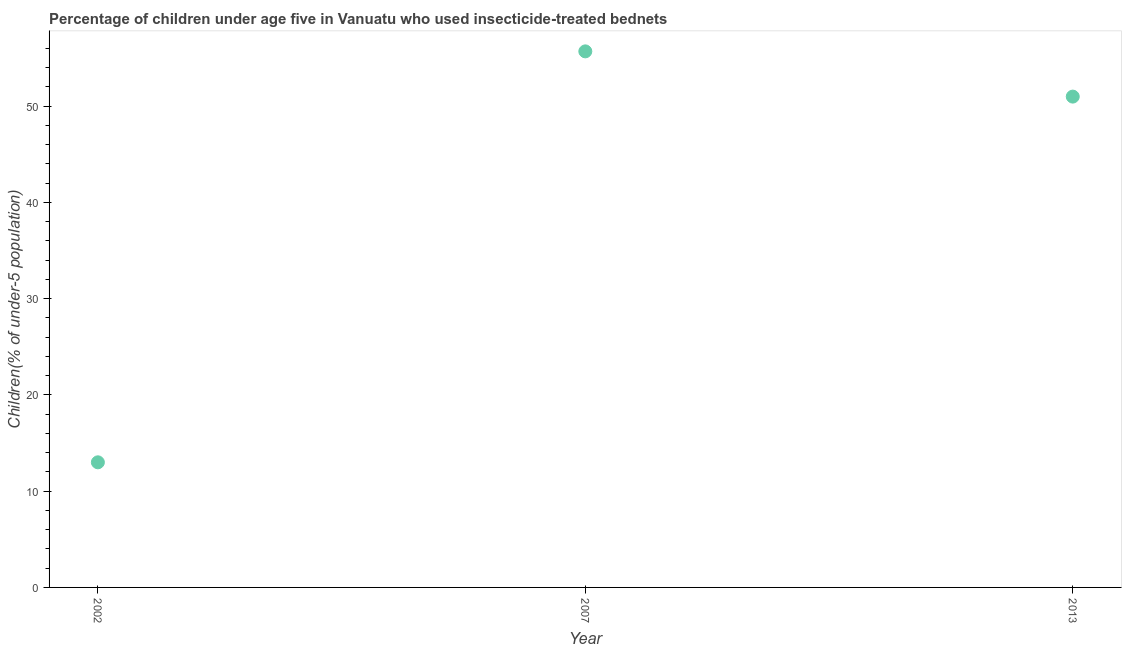What is the percentage of children who use of insecticide-treated bed nets in 2013?
Provide a short and direct response. 51. Across all years, what is the maximum percentage of children who use of insecticide-treated bed nets?
Provide a short and direct response. 55.7. What is the sum of the percentage of children who use of insecticide-treated bed nets?
Ensure brevity in your answer.  119.7. What is the difference between the percentage of children who use of insecticide-treated bed nets in 2007 and 2013?
Give a very brief answer. 4.7. What is the average percentage of children who use of insecticide-treated bed nets per year?
Give a very brief answer. 39.9. What is the ratio of the percentage of children who use of insecticide-treated bed nets in 2002 to that in 2013?
Make the answer very short. 0.25. Is the percentage of children who use of insecticide-treated bed nets in 2007 less than that in 2013?
Ensure brevity in your answer.  No. What is the difference between the highest and the second highest percentage of children who use of insecticide-treated bed nets?
Ensure brevity in your answer.  4.7. Is the sum of the percentage of children who use of insecticide-treated bed nets in 2007 and 2013 greater than the maximum percentage of children who use of insecticide-treated bed nets across all years?
Keep it short and to the point. Yes. What is the difference between the highest and the lowest percentage of children who use of insecticide-treated bed nets?
Provide a succinct answer. 42.7. Does the percentage of children who use of insecticide-treated bed nets monotonically increase over the years?
Your response must be concise. No. How many years are there in the graph?
Provide a succinct answer. 3. What is the difference between two consecutive major ticks on the Y-axis?
Offer a terse response. 10. Does the graph contain grids?
Your answer should be very brief. No. What is the title of the graph?
Provide a short and direct response. Percentage of children under age five in Vanuatu who used insecticide-treated bednets. What is the label or title of the X-axis?
Provide a succinct answer. Year. What is the label or title of the Y-axis?
Offer a very short reply. Children(% of under-5 population). What is the Children(% of under-5 population) in 2007?
Provide a succinct answer. 55.7. What is the difference between the Children(% of under-5 population) in 2002 and 2007?
Offer a terse response. -42.7. What is the difference between the Children(% of under-5 population) in 2002 and 2013?
Ensure brevity in your answer.  -38. What is the ratio of the Children(% of under-5 population) in 2002 to that in 2007?
Your answer should be compact. 0.23. What is the ratio of the Children(% of under-5 population) in 2002 to that in 2013?
Keep it short and to the point. 0.26. What is the ratio of the Children(% of under-5 population) in 2007 to that in 2013?
Your response must be concise. 1.09. 